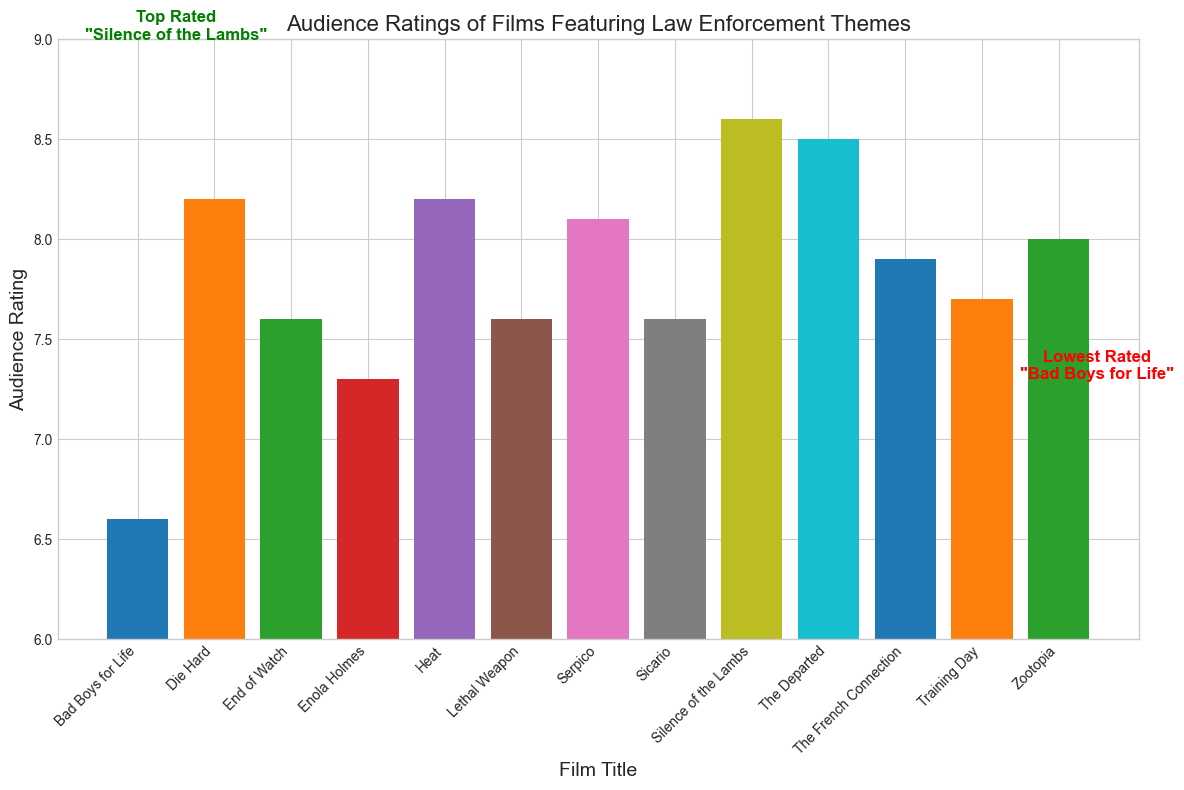Which film has the highest audience rating? According to the highest bar on the chart, "Silence of the Lambs" has the highest audience rating as highlighted by the green annotation.
Answer: Silence of the Lambs What is the average audience rating for films from the 2010s? Sum the ratings for "End of Watch" (7.6), "Zootopia" (8.0), and "Sicario" (7.6), then divide by 3 to find the average: (7.6 + 8.0 + 7.6) / 3 = 7.73.
Answer: 7.73 How does the audience rating of "Die Hard" compare to "The French Connection"? "Die Hard" has an audience rating of 8.2, while "The French Connection" has a rating of 7.9. 8.2 is greater than 7.9.
Answer: "Die Hard" has a higher rating Which film is rated the lowest? The red annotation highlights "Bad Boys for Life" as the lowest-rated film with a 6.6 rating.
Answer: Bad Boys for Life What is the difference between the audience ratings of "Heat" and "End of Watch"? "Heat" has a rating of 8.2, and "End of Watch" has a rating of 7.6. The difference is 8.2 - 7.6 = 0.6.
Answer: 0.6 Are there any films with the same audience rating and, if so, which ones? Both "Lethal Weapon" and "Sicario" have an audience rating of 7.6 as indicated by the same height of their respective bars.
Answer: Lethal Weapon and Sicario How many films have an audience rating of above 8? Count the bars that are taller than the 8.0 mark. These films are "Serpico," "Die Hard," "Silence of the Lambs," "Heat," and "The Departed," totaling 5.
Answer: 5 What is the audience rating for the film with the highest rated crime genre in the 2000s? The highest-rated crime genre film in the 2000s is "The Departed" with a rating of 8.5.
Answer: 8.5 Which decade has the most films in the chart and how many films are from that decade? Count the number of films per decade: 1970s (2), 1980s (2), 1990s (2), 2000s (2), 2010s (3), 2020s (2). The decade with the most films is the 2010s, with 3 films.
Answer: 2010s with 3 films What is the combined audience rating of all the films in the Action genre? Sum the ratings for "The French Connection" (7.9), "Lethal Weapon" (7.6), "Die Hard" (8.2), "End of Watch" (7.6), and "Bad Boys for Life" (6.6). The total is 7.9 + 7.6 + 8.2 + 7.6 + 6.6 = 37.9.
Answer: 37.9 